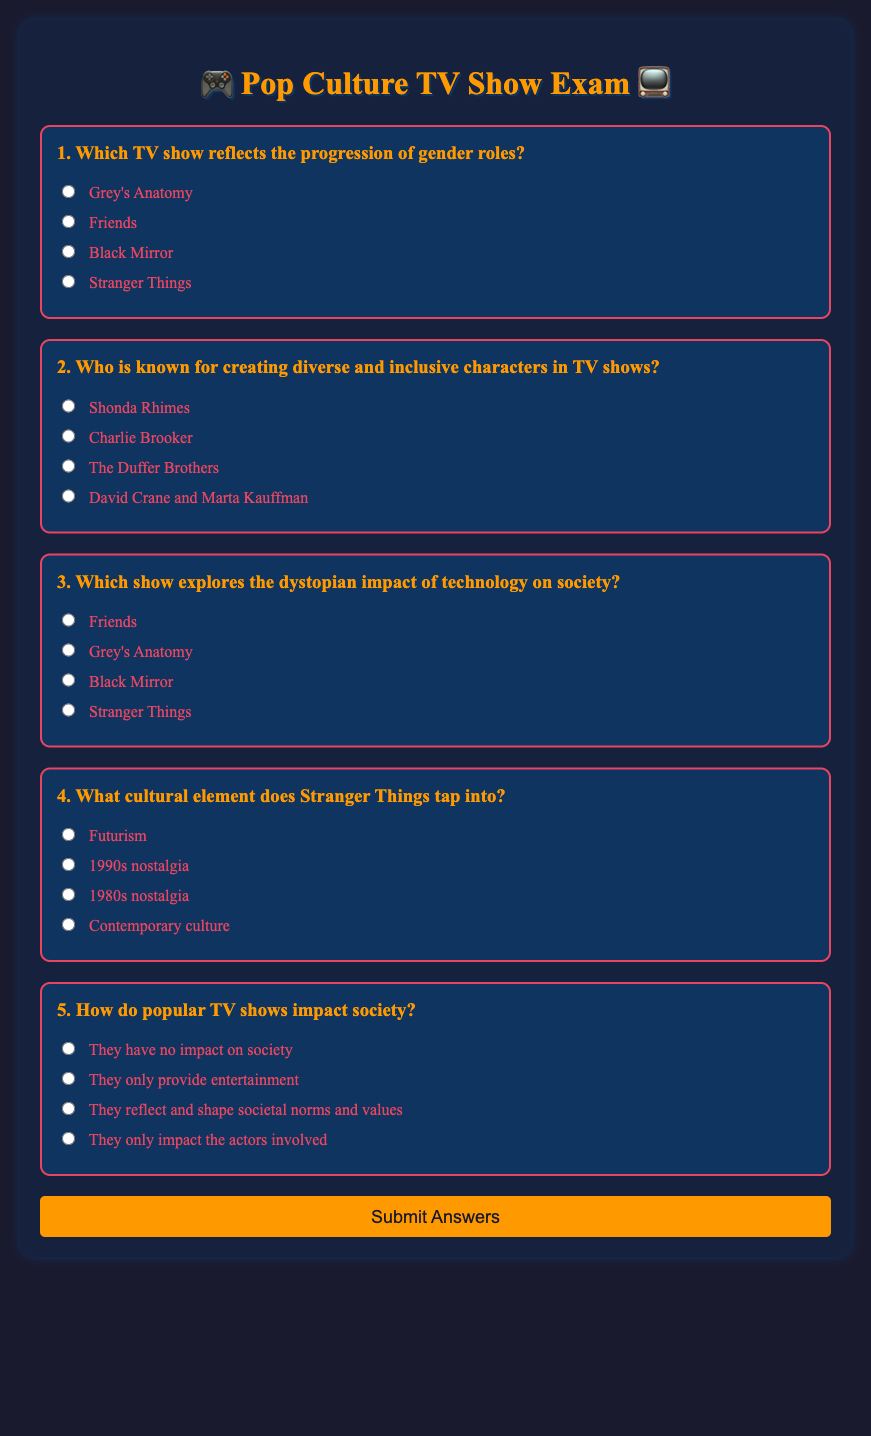What is the title of the exam? The title of the exam is prominently displayed at the top of the document as "Pop Culture TV Show Exam".
Answer: Pop Culture TV Show Exam Who created the question regarding the reflection of gender roles? The question regarding the reflection of gender roles is found in question 1, which has the options listed below it.
Answer: Grey's Anatomy What is the primary theme of the show "Black Mirror"? The theme of "Black Mirror" is addressed in question 3, which specifically asks about technology's impact on society.
Answer: Dystopian impact of technology Which decade's nostalgia is explored in "Stranger Things"? The cultural element tapped into by "Stranger Things" is specified in question 4, which focuses on nostalgia from a particular decade.
Answer: 1980s nostalgia How many questions are in the exam? The document contains a total of five questions, each with multiple-choice answers.
Answer: Five 